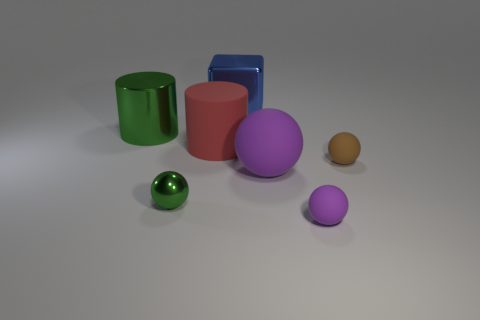Add 2 big brown rubber cylinders. How many objects exist? 9 Subtract all cylinders. How many objects are left? 5 Add 3 large rubber cylinders. How many large rubber cylinders exist? 4 Subtract 0 brown cylinders. How many objects are left? 7 Subtract all purple blocks. Subtract all big rubber spheres. How many objects are left? 6 Add 3 large purple matte balls. How many large purple matte balls are left? 4 